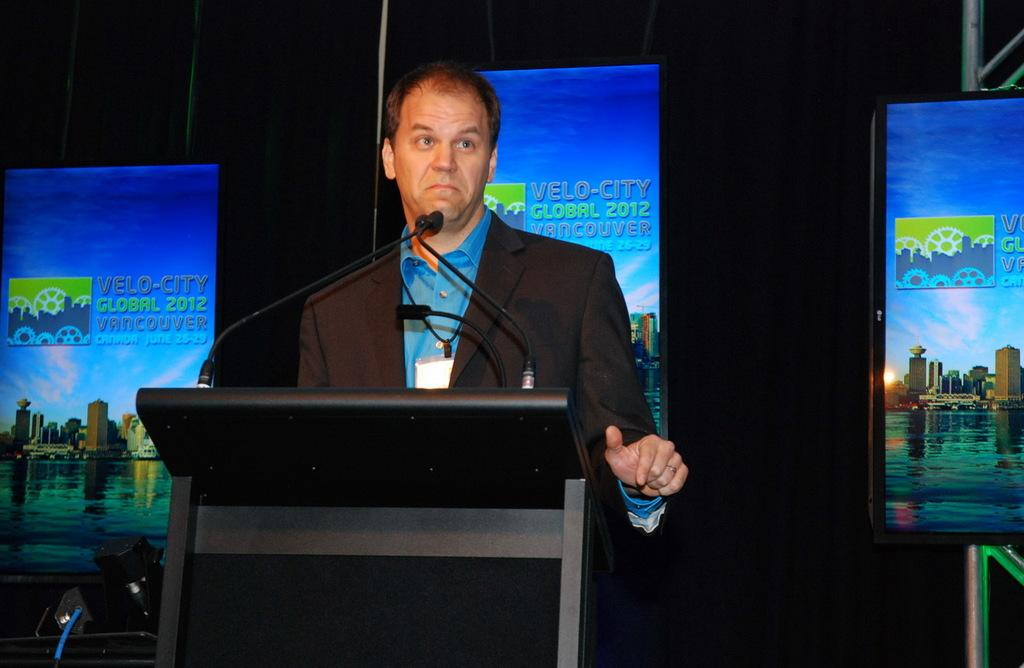<image>
Summarize the visual content of the image. A man standing at a podium with a Velo-city logo behind him. 